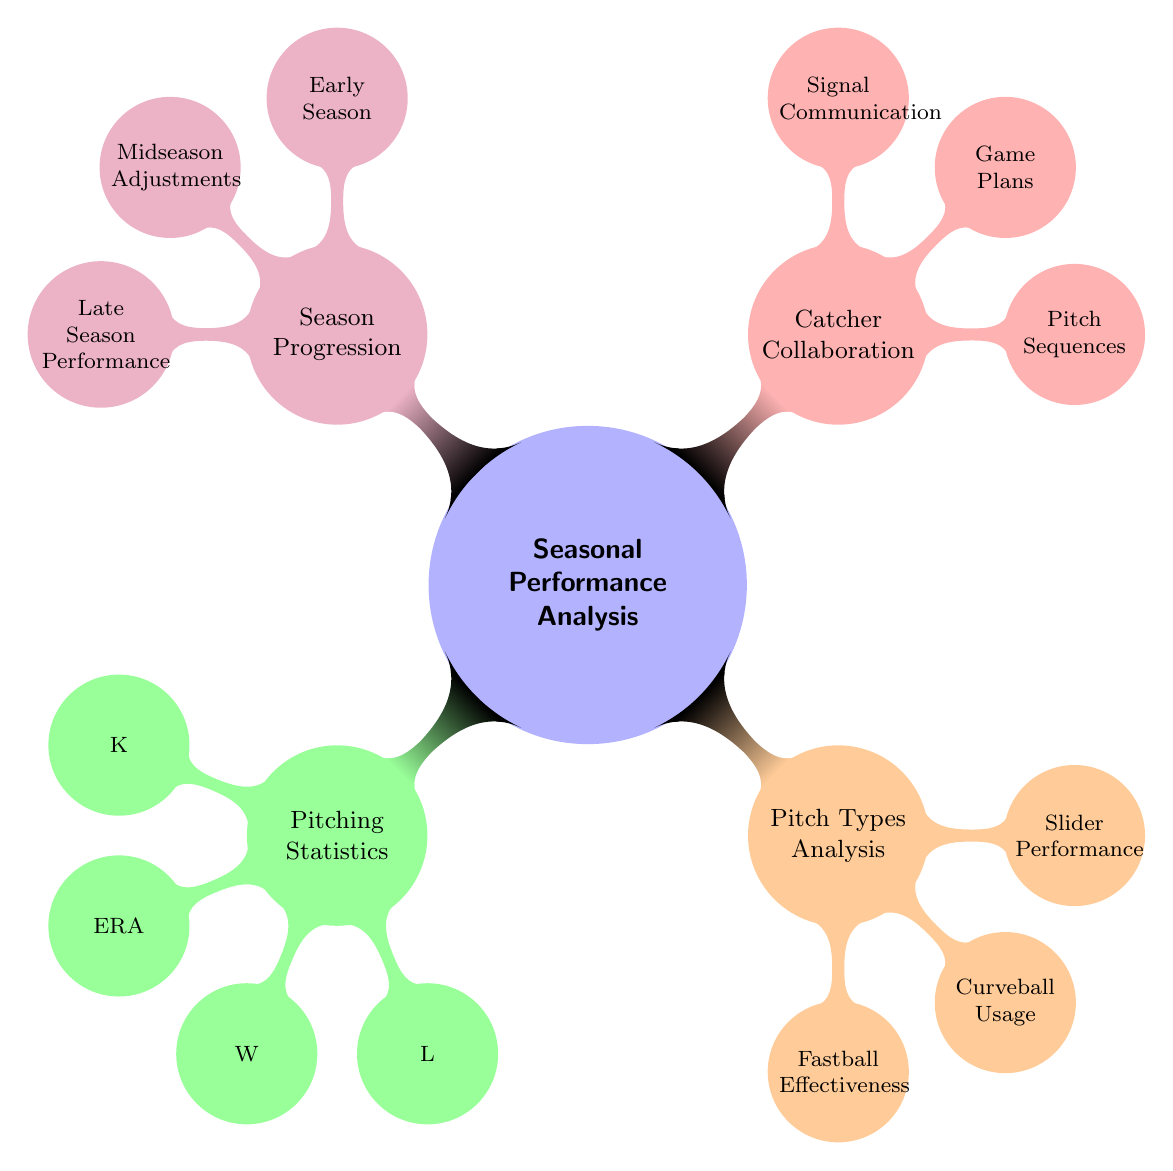What are the four main categories in the mind map? The mind map consists of four main categories: Pitching Statistics, Pitch Types Analysis, Catcher Collaboration, and Season Progression. Each of these categories represents a key area of focus during the seasonal performance analysis.
Answer: Pitching Statistics, Pitch Types Analysis, Catcher Collaboration, Season Progression How many nodes are there under Pitching Statistics? Under Pitching Statistics, there are four nodes: Strikeouts, Earned Run Average, Wins, and Losses. Counting these gives a total of four nodes.
Answer: Four What is one performance measure in Pitch Types Analysis? One performance measure listed in Pitch Types Analysis is Fastball Effectiveness. This is a specific focus area related to the effectiveness of the fastball pitch, highlighting its significance in performance analysis.
Answer: Fastball Effectiveness What does Catcher Collaboration include? Catcher Collaboration includes three nodes: Pitch Sequences, Game Plans, and Signal Communication. These nodes focus on the collaboration process between the pitcher and catcher during games.
Answer: Pitch Sequences, Game Plans, Signal Communication In which season phase would you focus on technique refinement? Technique refinement is emphasized during the Midseason Adjustments phase. This is when evaluations and improvements in technique typically take place to enhance performance in the latter part of the season.
Answer: Midseason Adjustments What performance aspect is related to the Curveball Usage? The performance aspect related to Curveball Usage is Strike Rate. This statistic measures how effectively the curveball pitch results in strikes, indicating the effectiveness of this particular pitch type.
Answer: Strike Rate How does the structure of the mind map visualize relationships between performance aspects? The structure visualizes relationships by organizing categories into primary themes and sub-nodes, clearly showing how each aspect of seasonal performance is interconnected and dependent on the others for analysis.
Answer: Interconnected themes What is the suggested focus during the Late Season Performance? The suggested focus during Late Season Performance is on Stamina and Playoff Preparation. This indicates a transition towards ensuring physical readiness for the postseason.
Answer: Stamina, Playoff Prep 